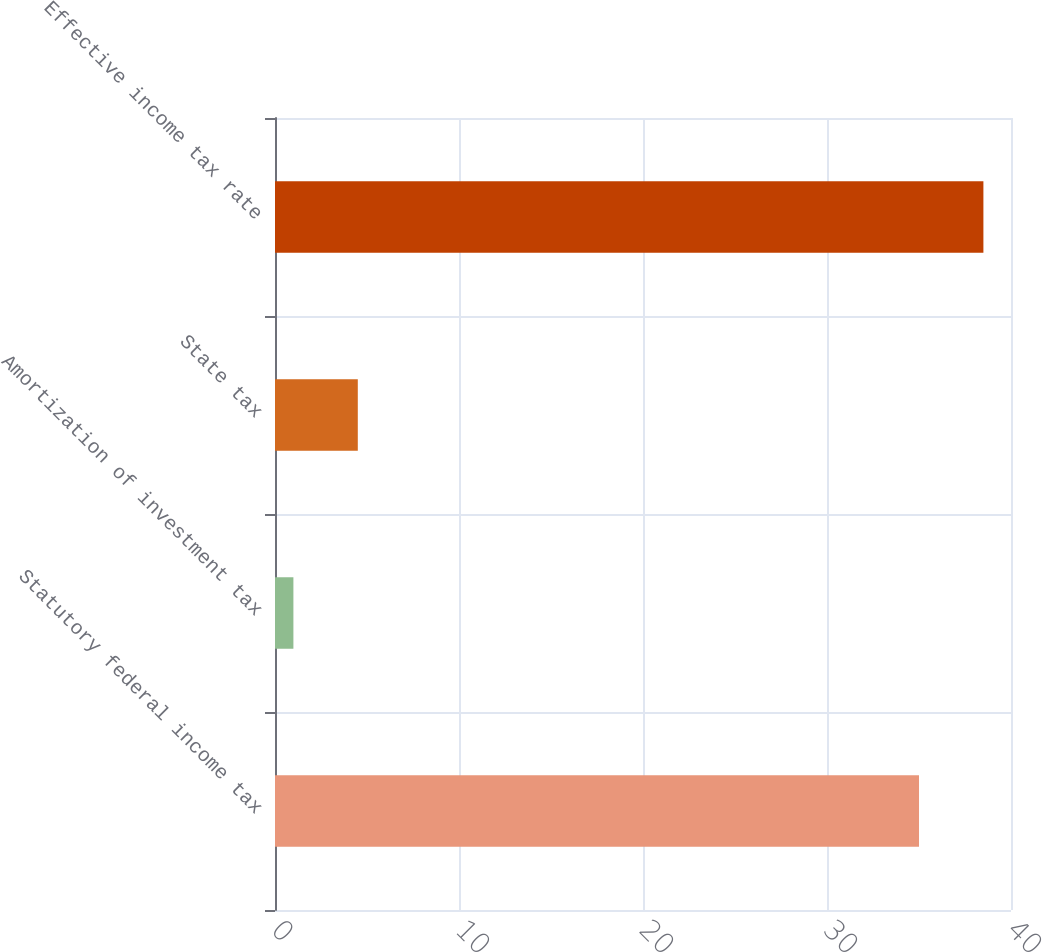<chart> <loc_0><loc_0><loc_500><loc_500><bar_chart><fcel>Statutory federal income tax<fcel>Amortization of investment tax<fcel>State tax<fcel>Effective income tax rate<nl><fcel>35<fcel>1<fcel>4.5<fcel>38.5<nl></chart> 